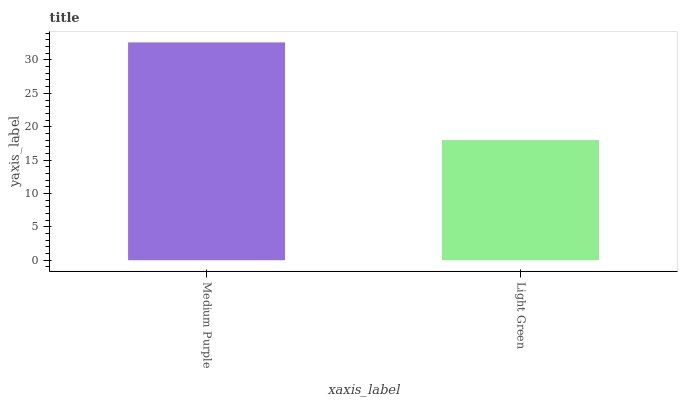Is Light Green the minimum?
Answer yes or no. Yes. Is Medium Purple the maximum?
Answer yes or no. Yes. Is Light Green the maximum?
Answer yes or no. No. Is Medium Purple greater than Light Green?
Answer yes or no. Yes. Is Light Green less than Medium Purple?
Answer yes or no. Yes. Is Light Green greater than Medium Purple?
Answer yes or no. No. Is Medium Purple less than Light Green?
Answer yes or no. No. Is Medium Purple the high median?
Answer yes or no. Yes. Is Light Green the low median?
Answer yes or no. Yes. Is Light Green the high median?
Answer yes or no. No. Is Medium Purple the low median?
Answer yes or no. No. 